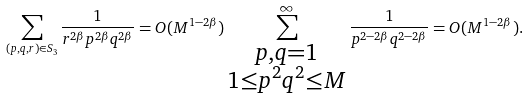Convert formula to latex. <formula><loc_0><loc_0><loc_500><loc_500>\sum _ { ( p , q , r ) \in S _ { 3 } } \frac { 1 } { r ^ { 2 \beta } p ^ { 2 \beta } q ^ { 2 \beta } } = O ( M ^ { 1 - 2 \beta } ) \sum _ { \substack { p , q = 1 \\ 1 \leq p ^ { 2 } q ^ { 2 } \leq M } } ^ { \infty } \frac { 1 } { p ^ { 2 - 2 \beta } q ^ { 2 - 2 \beta } } = O ( M ^ { 1 - 2 \beta } ) .</formula> 